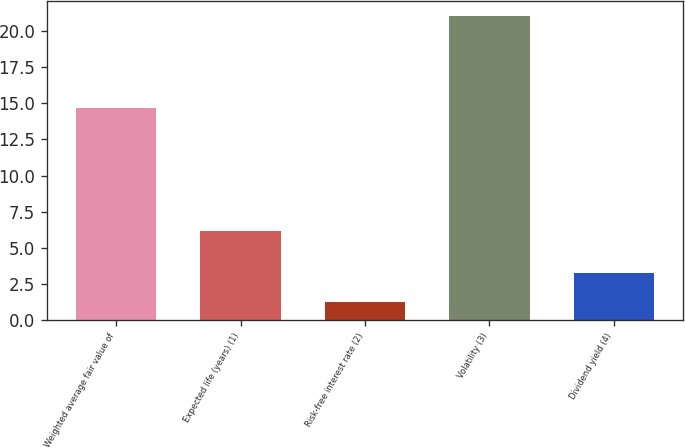Convert chart. <chart><loc_0><loc_0><loc_500><loc_500><bar_chart><fcel>Weighted average fair value of<fcel>Expected life (years) (1)<fcel>Risk-free interest rate (2)<fcel>Volatility (3)<fcel>Dividend yield (4)<nl><fcel>14.7<fcel>6.18<fcel>1.26<fcel>21.07<fcel>3.24<nl></chart> 